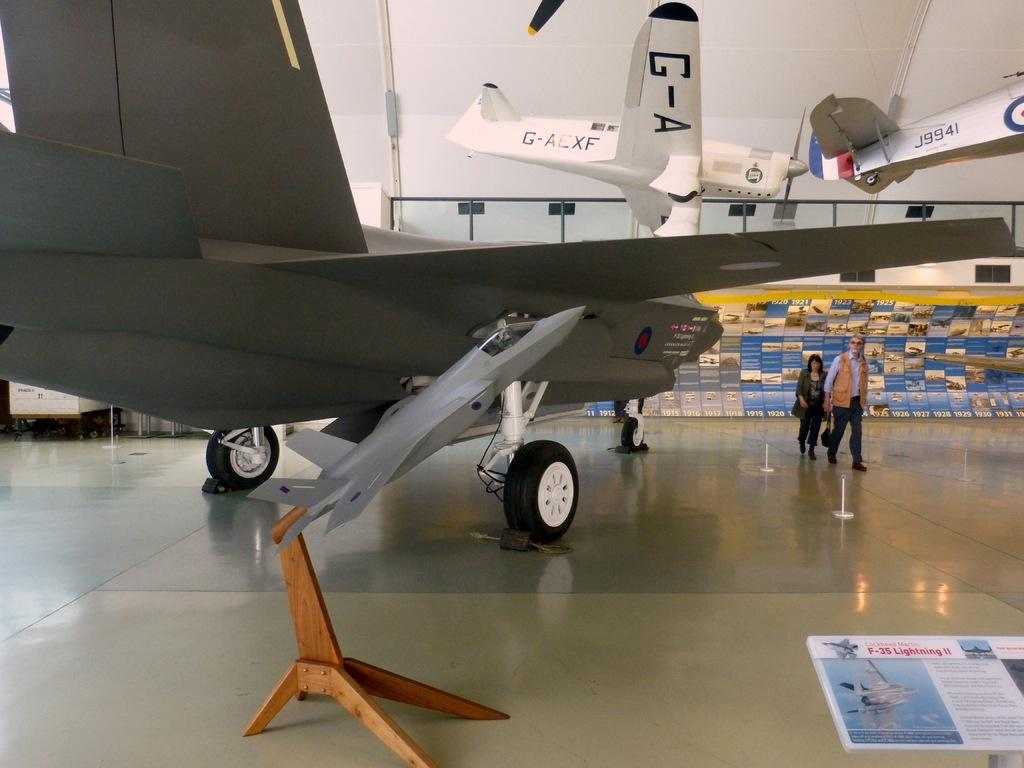<image>
Render a clear and concise summary of the photo. a plane with g-4 on the side of it 